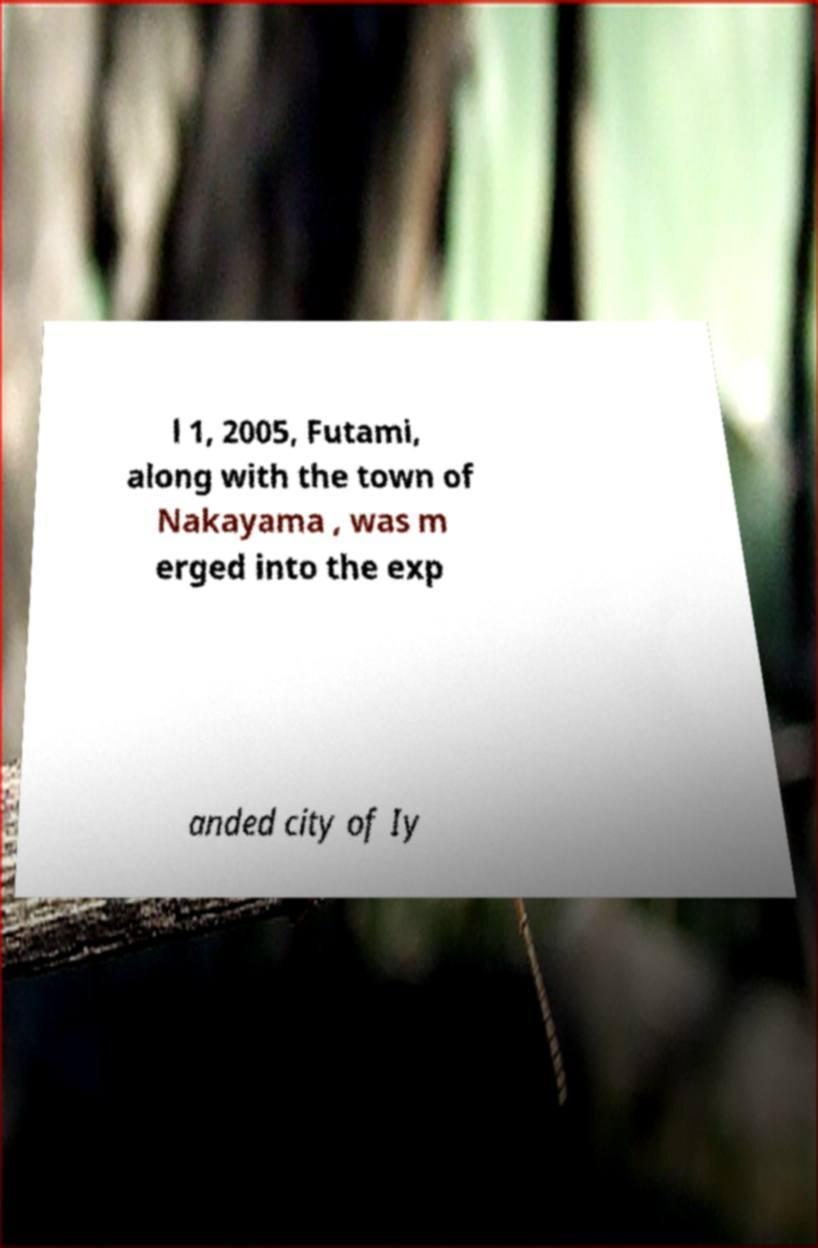For documentation purposes, I need the text within this image transcribed. Could you provide that? l 1, 2005, Futami, along with the town of Nakayama , was m erged into the exp anded city of Iy 